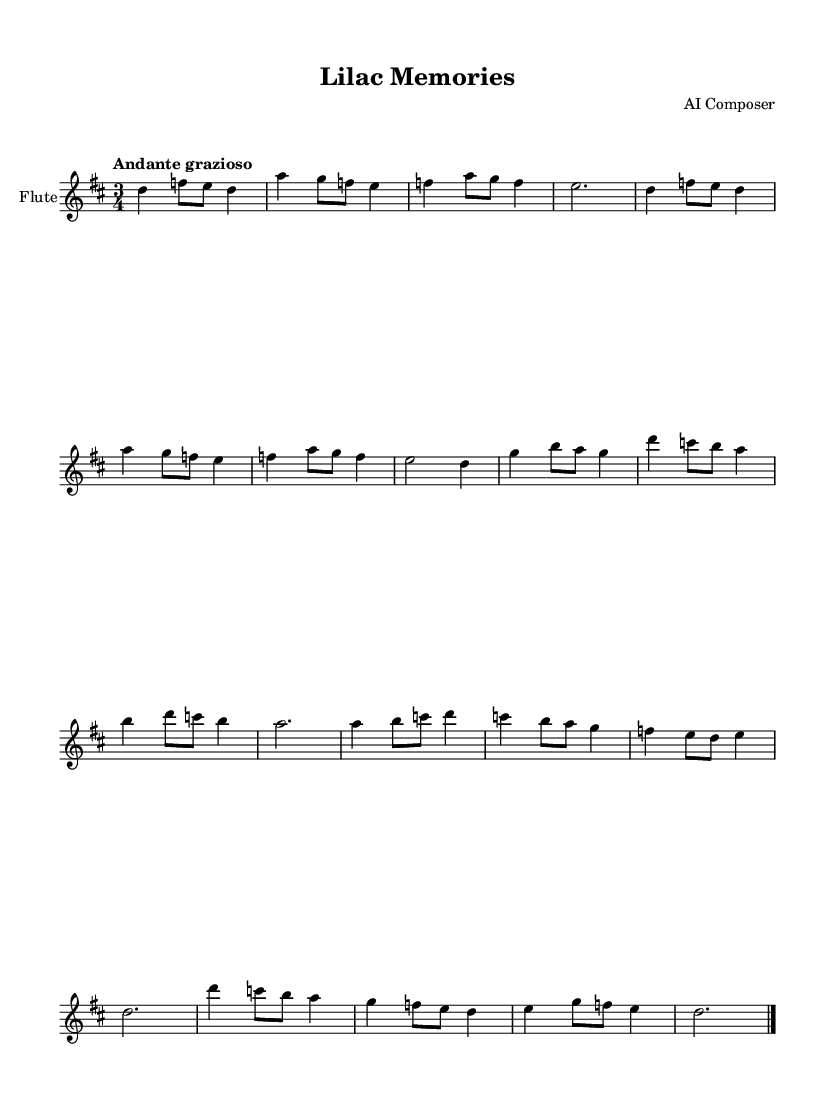What is the key signature of this music? The key signature is indicated at the beginning of the staff, which shows two sharps. This corresponds to D major, where F# and C# are the two sharps.
Answer: D major What is the time signature of this music? The time signature is displayed as a fraction at the beginning of the staff, showing 3/4. This means there are three beats in each measure, and the quarter note gets one beat.
Answer: 3/4 What is the indicated tempo for this piece? The tempo is listed in Italian at the beginning of the piece, stating "Andante grazioso," which means to play at a moderate pace with grace.
Answer: Andante grazioso How many musical themes are present in this composition? The sheet music shows distinct sections labeled as "Theme A" and "Theme B," indicating that there are two separate themes in the piece.
Answer: Two In what meter does the piece conclude? The piece ends with the same time signature of 3/4 present throughout, and the final bar is marked with an ending sign indicating the piece's closure, confirming its continuity in meter.
Answer: 3/4 What is the highest note played by the flute in the piece? The highest note can be identified in the melody, where the flute reaches a D note in the 8th measure of Theme A, showing it as the highest pitch in this context.
Answer: D How many measures are in Theme A? By counting the measures outlined in Theme A from the notation, there are a total of 8 measures comprising the theme.
Answer: Eight 